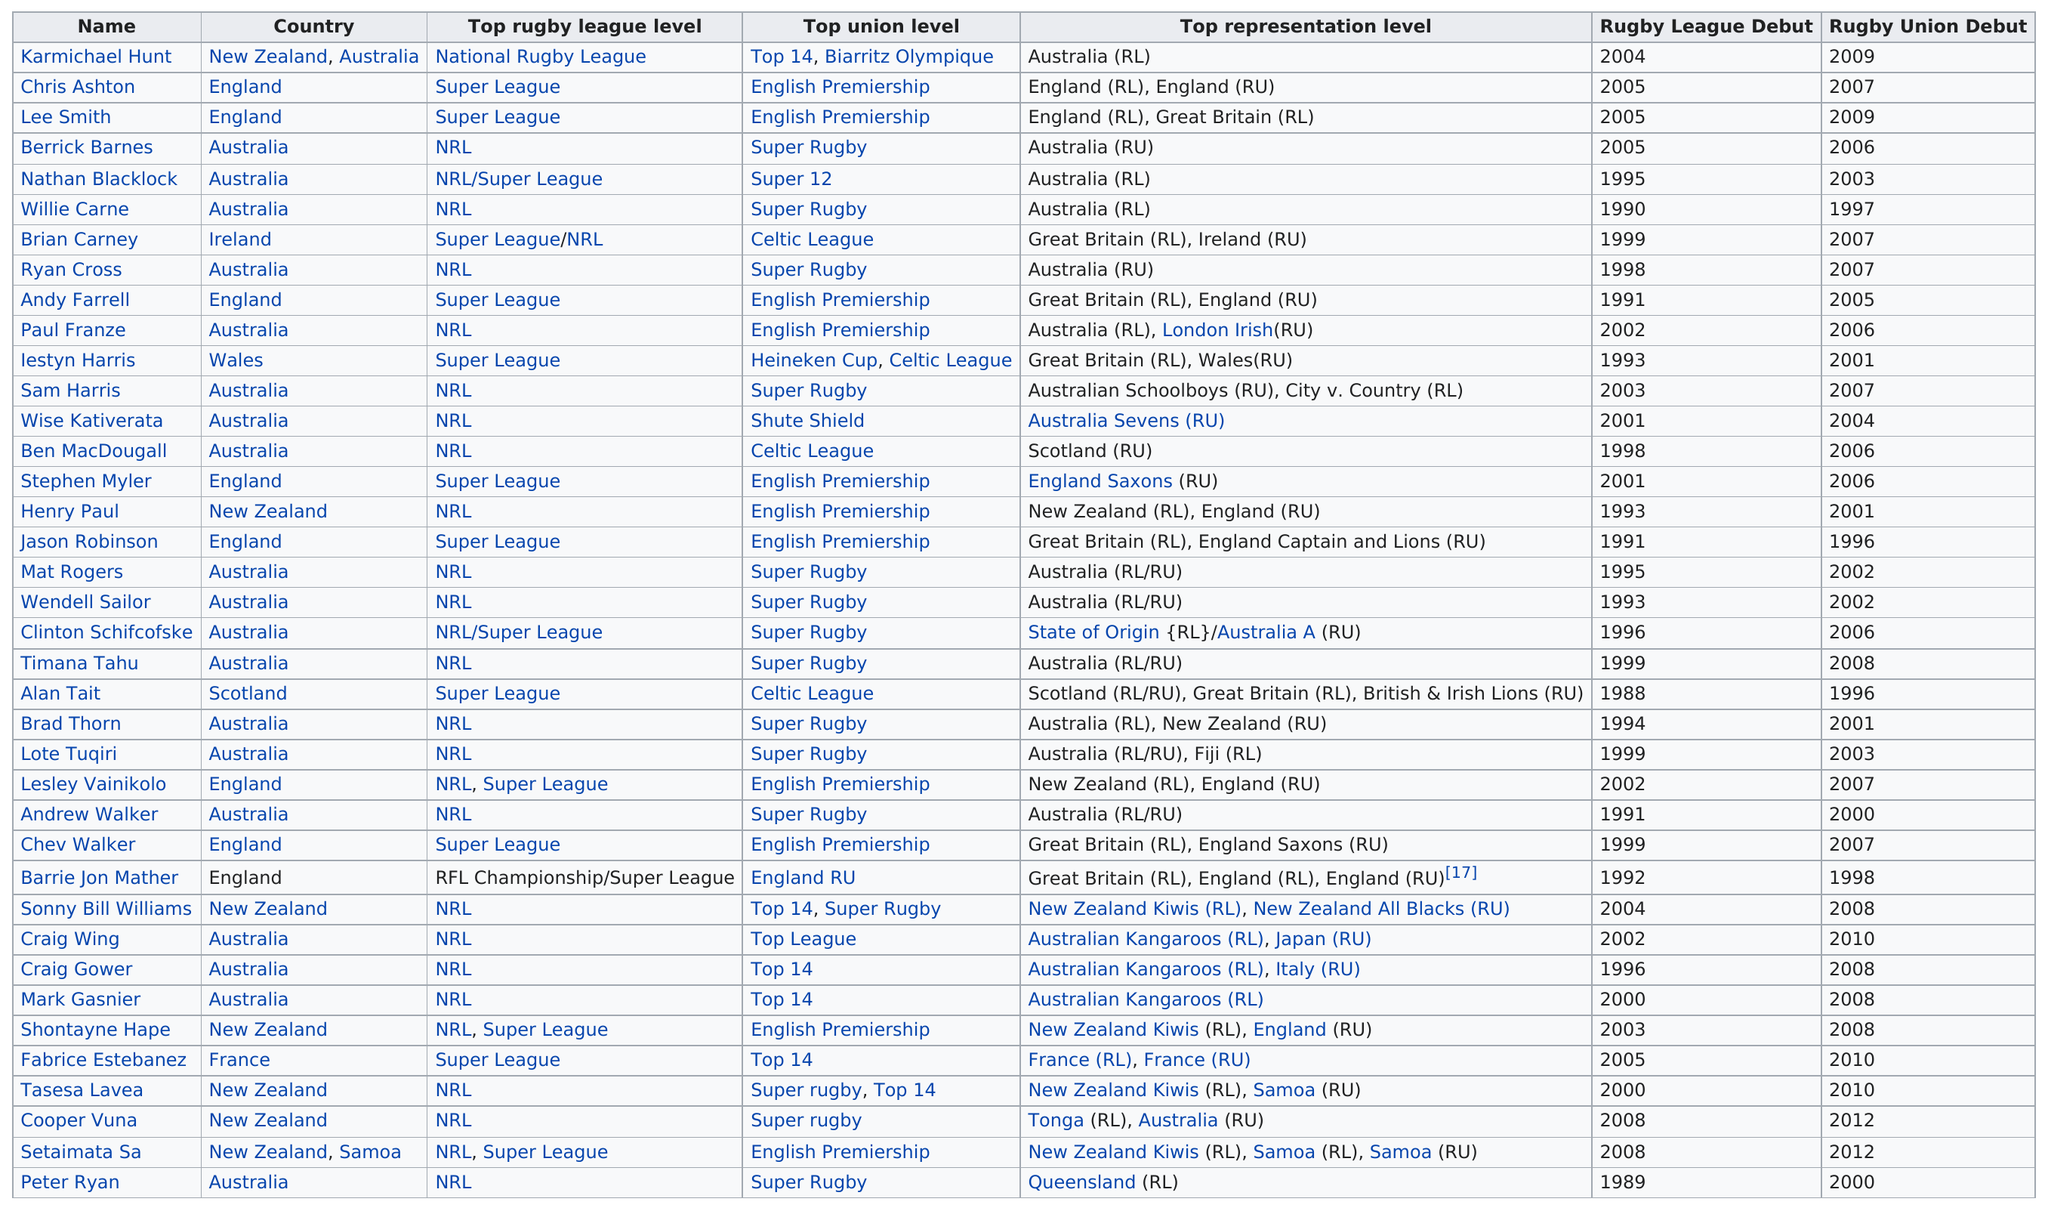Mention a couple of crucial points in this snapshot. Sonny Bill Williams, a player who has represented New Zealand both as a Kiwis and the All Blacks, has played for these two teams. It is not clear whether Karmichael Hunt or Chris Ashton played at the top level of rugby league in the Super League. Chris Ashton, however, is known to have played at this level. Ireland is listed as the country that is least featured. I call upon the witness to provide a player who made their professional debut in a league and then joined the NFL Union at least 8 years later. The player is Andy Farrell. Karmichael Hunt's name appears before Chris Ashton's on the list. 